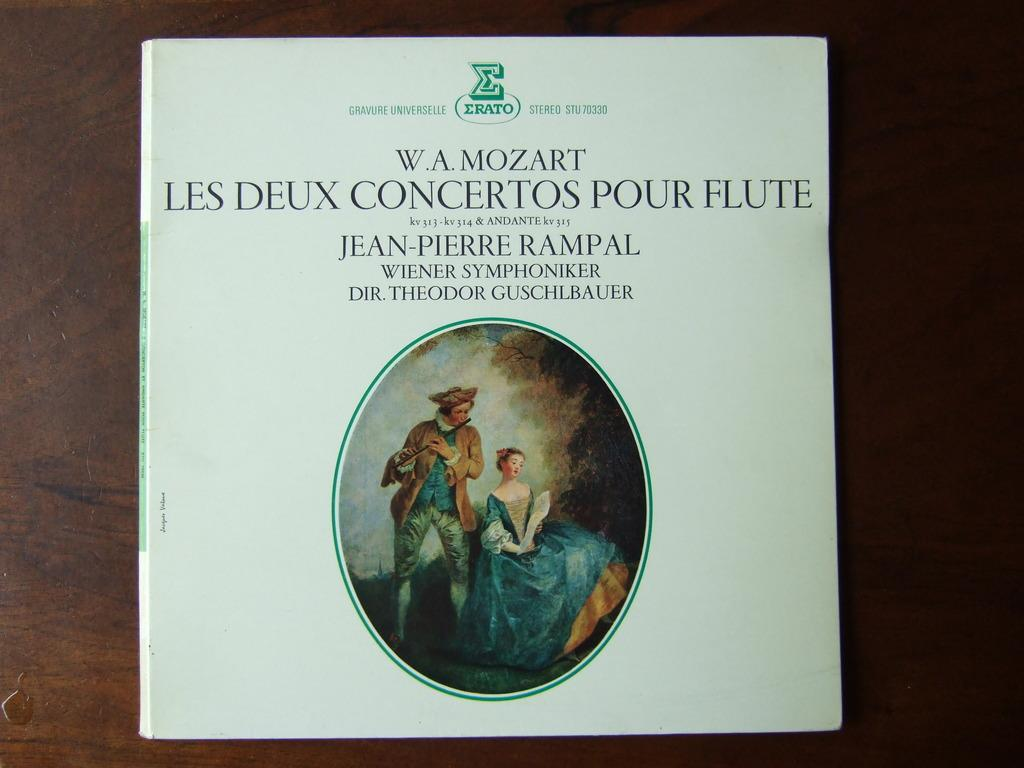<image>
Give a short and clear explanation of the subsequent image. A Mozart album has an illustration of a man playing a flute and a woman sitting next to him. 